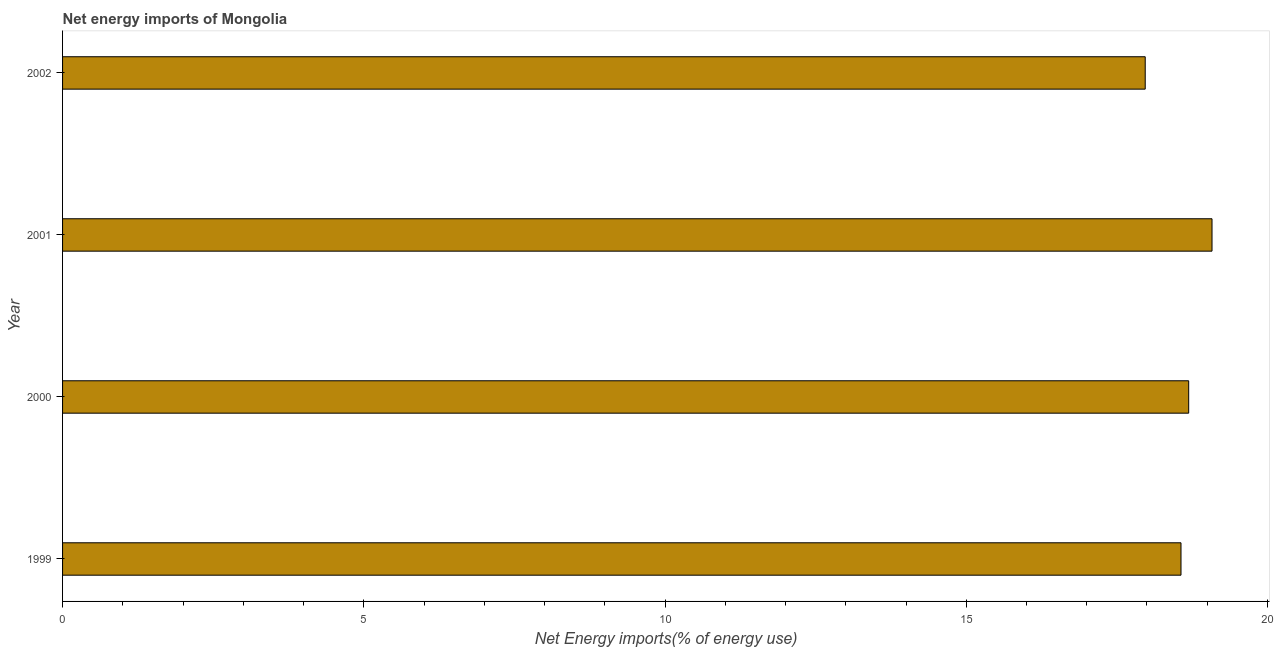Does the graph contain any zero values?
Offer a terse response. No. Does the graph contain grids?
Your response must be concise. No. What is the title of the graph?
Offer a very short reply. Net energy imports of Mongolia. What is the label or title of the X-axis?
Make the answer very short. Net Energy imports(% of energy use). What is the energy imports in 2001?
Make the answer very short. 19.08. Across all years, what is the maximum energy imports?
Offer a very short reply. 19.08. Across all years, what is the minimum energy imports?
Your answer should be compact. 17.97. In which year was the energy imports minimum?
Provide a succinct answer. 2002. What is the sum of the energy imports?
Keep it short and to the point. 74.31. What is the difference between the energy imports in 2000 and 2001?
Your answer should be compact. -0.39. What is the average energy imports per year?
Your answer should be very brief. 18.58. What is the median energy imports?
Your response must be concise. 18.63. In how many years, is the energy imports greater than 14 %?
Offer a very short reply. 4. Do a majority of the years between 2002 and 2001 (inclusive) have energy imports greater than 2 %?
Provide a succinct answer. No. What is the ratio of the energy imports in 1999 to that in 2002?
Make the answer very short. 1.03. Is the energy imports in 2001 less than that in 2002?
Provide a succinct answer. No. What is the difference between the highest and the second highest energy imports?
Your answer should be compact. 0.39. What is the difference between the highest and the lowest energy imports?
Offer a very short reply. 1.11. In how many years, is the energy imports greater than the average energy imports taken over all years?
Offer a terse response. 2. What is the difference between two consecutive major ticks on the X-axis?
Provide a short and direct response. 5. Are the values on the major ticks of X-axis written in scientific E-notation?
Provide a short and direct response. No. What is the Net Energy imports(% of energy use) in 1999?
Your response must be concise. 18.56. What is the Net Energy imports(% of energy use) of 2000?
Your answer should be compact. 18.69. What is the Net Energy imports(% of energy use) in 2001?
Ensure brevity in your answer.  19.08. What is the Net Energy imports(% of energy use) in 2002?
Offer a very short reply. 17.97. What is the difference between the Net Energy imports(% of energy use) in 1999 and 2000?
Your answer should be compact. -0.13. What is the difference between the Net Energy imports(% of energy use) in 1999 and 2001?
Ensure brevity in your answer.  -0.51. What is the difference between the Net Energy imports(% of energy use) in 1999 and 2002?
Make the answer very short. 0.59. What is the difference between the Net Energy imports(% of energy use) in 2000 and 2001?
Your response must be concise. -0.39. What is the difference between the Net Energy imports(% of energy use) in 2000 and 2002?
Offer a terse response. 0.72. What is the difference between the Net Energy imports(% of energy use) in 2001 and 2002?
Offer a very short reply. 1.11. What is the ratio of the Net Energy imports(% of energy use) in 1999 to that in 2000?
Your answer should be compact. 0.99. What is the ratio of the Net Energy imports(% of energy use) in 1999 to that in 2001?
Keep it short and to the point. 0.97. What is the ratio of the Net Energy imports(% of energy use) in 1999 to that in 2002?
Give a very brief answer. 1.03. What is the ratio of the Net Energy imports(% of energy use) in 2000 to that in 2001?
Your answer should be compact. 0.98. What is the ratio of the Net Energy imports(% of energy use) in 2001 to that in 2002?
Your answer should be compact. 1.06. 